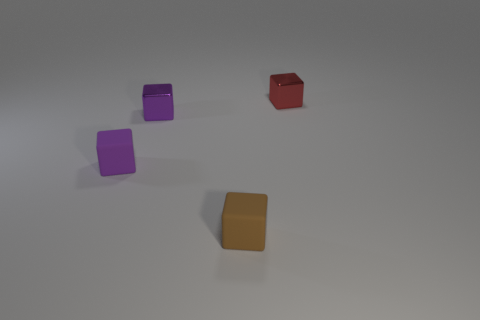Add 2 large red rubber balls. How many objects exist? 6 Add 3 tiny green metallic spheres. How many tiny green metallic spheres exist? 3 Subtract 0 purple spheres. How many objects are left? 4 Subtract all shiny cubes. Subtract all purple things. How many objects are left? 0 Add 4 tiny red shiny cubes. How many tiny red shiny cubes are left? 5 